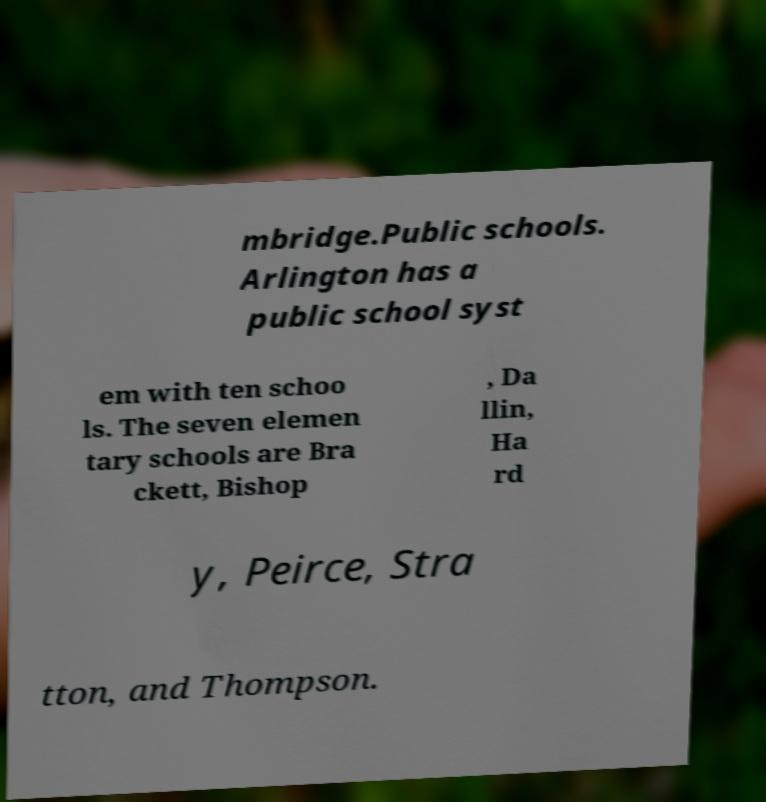There's text embedded in this image that I need extracted. Can you transcribe it verbatim? mbridge.Public schools. Arlington has a public school syst em with ten schoo ls. The seven elemen tary schools are Bra ckett, Bishop , Da llin, Ha rd y, Peirce, Stra tton, and Thompson. 